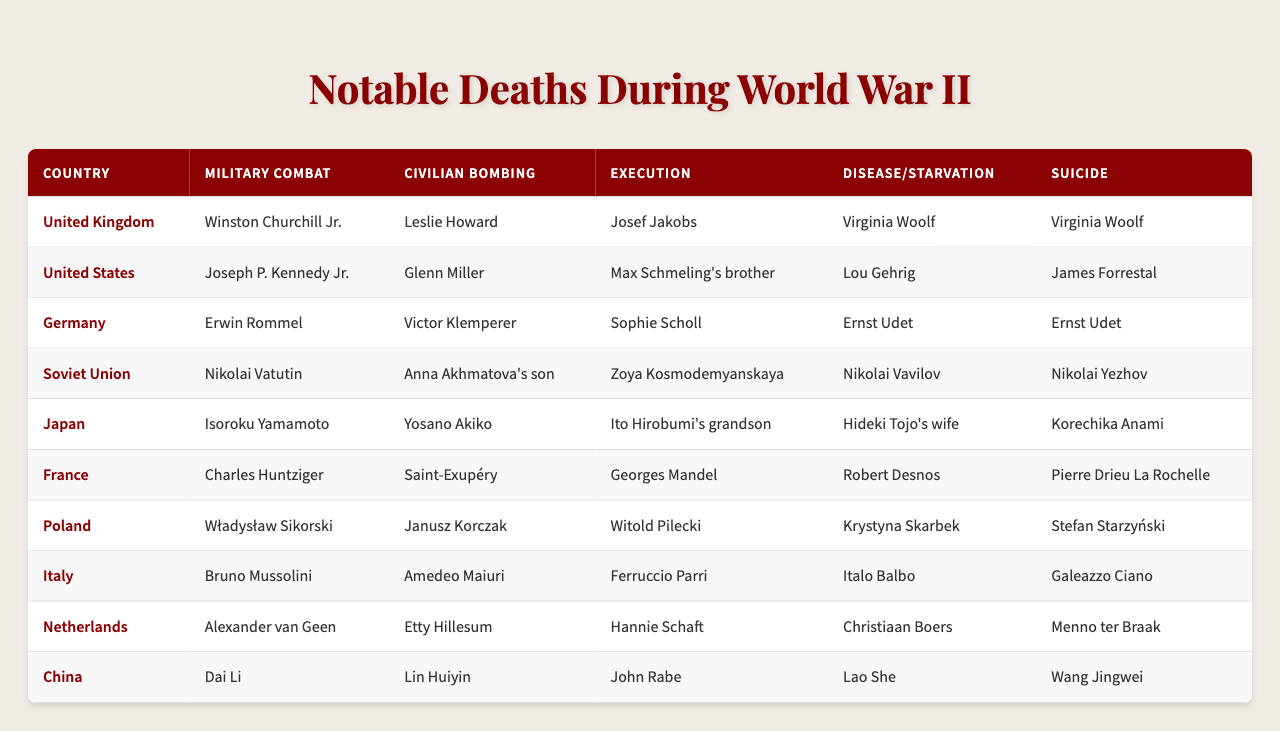What notable individual from the United Kingdom died due to military combat? Referring to the table under the "United Kingdom" row in the "Military Combat" column, the notable individual listed is Winston Churchill Jr.
Answer: Winston Churchill Jr Which country had the notable figure who died from civilian bombing and was also a famous musician? Looking under the "Civilian Bombing" column, Glenn Miller is the notable figure associated with the United States who was a famous musician.
Answer: United States Did any notable figures from Poland die by execution during World War II? In the "Execution" column for Poland, the answer is Witold Pilecki. This confirms that Poland did have notable individuals who died by execution.
Answer: Yes How many individuals listed died due to disease or starvation in total across all countries? Summing the notable figures under the "Disease/Starvation" column, we count 10 individuals, one from each country listed.
Answer: 10 Who are the notable individuals from Germany that died by suicide? Referring to the "Suicide" column for Germany, the notable individual listed is Ernst Udet.
Answer: Ernst Udet Which country has the highest number of notable deaths listed under execution? By comparing the names in the "Execution" column, each country has only one individual listed for execution, so no country has more than another.
Answer: None What was the main cause of death for Władysław Sikorski? Checking the "Military Combat" column for Poland, Władysław Sikorski is noted under military combat.
Answer: Military Combat Is there a notable individual from Japan who died due to civilian bombing? Looking at the "Civilian Bombing" column for Japan, Yosano Akiko is listed, indicating that there was a notable individual who died from that cause.
Answer: Yes How many notable individuals listed from the Soviet Union died by execution compared to those who died from disease/starvation? The Soviet Union has Zoya Kosmodemyanskaya under execution and Nikolai Vavilov under disease/starvation. Thus, it is one for execution and one for disease/starvation.
Answer: Both have 1 What was the notable cause of death for Isoroku Yamamoto? Under the "Military Combat" column for Japan, Isoroku Yamamoto is listed as a notable individual who died due to military combat.
Answer: Military Combat 